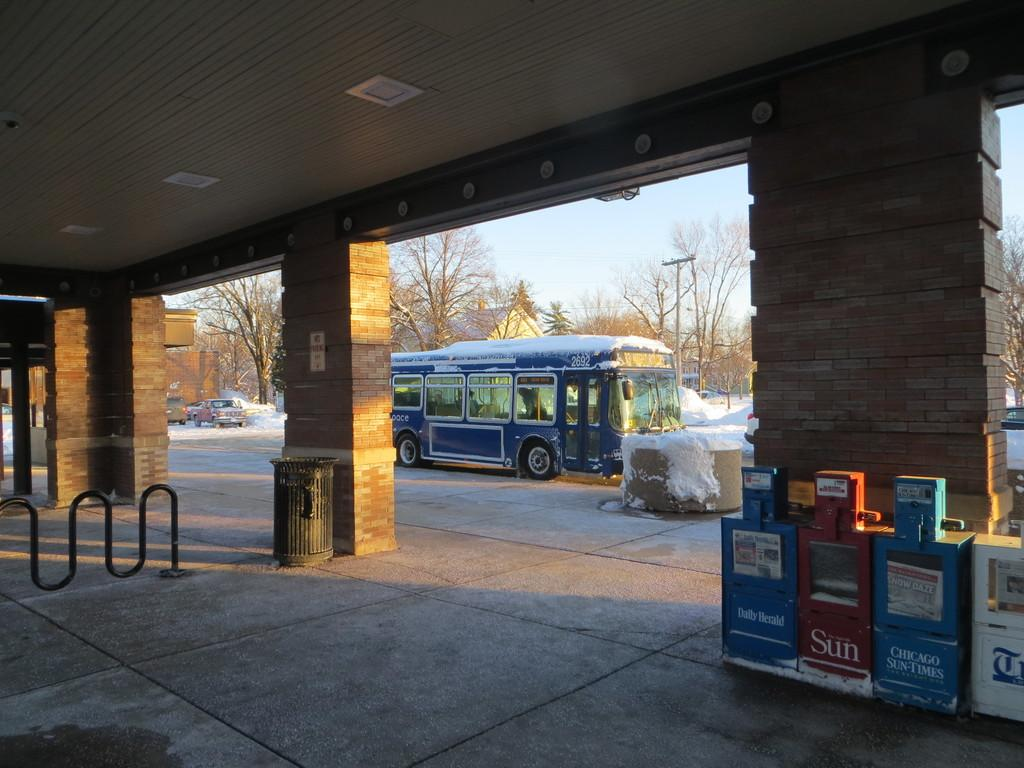What objects are present in the image? There are boxes and a dustbin in the image. What can be seen in the background of the image? In the background, there is snow, vehicles, a pole, trees, and buildings. How many elements are present in the background of the image? There are five elements present in the background: snow, vehicles, a pole, trees, and buildings. What type of guide can be seen holding a balloon in the image? There is no guide or balloon present in the image. 